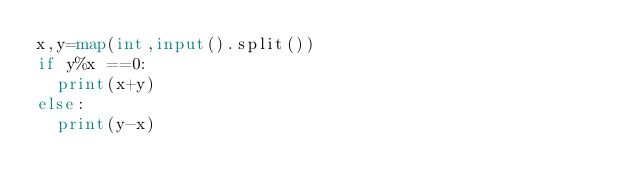Convert code to text. <code><loc_0><loc_0><loc_500><loc_500><_Python_>x,y=map(int,input().split())
if y%x ==0:
  print(x+y)
else:
  print(y-x)</code> 